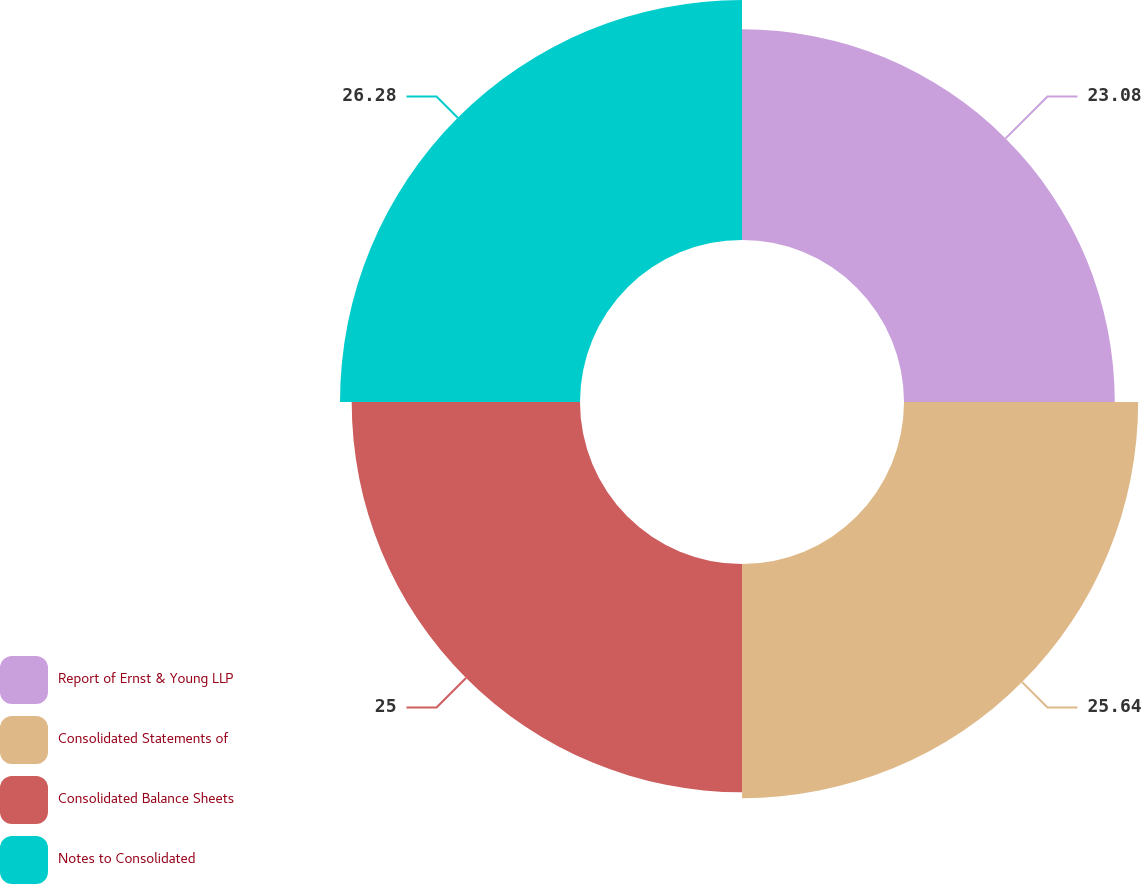<chart> <loc_0><loc_0><loc_500><loc_500><pie_chart><fcel>Report of Ernst & Young LLP<fcel>Consolidated Statements of<fcel>Consolidated Balance Sheets<fcel>Notes to Consolidated<nl><fcel>23.08%<fcel>25.64%<fcel>25.0%<fcel>26.28%<nl></chart> 